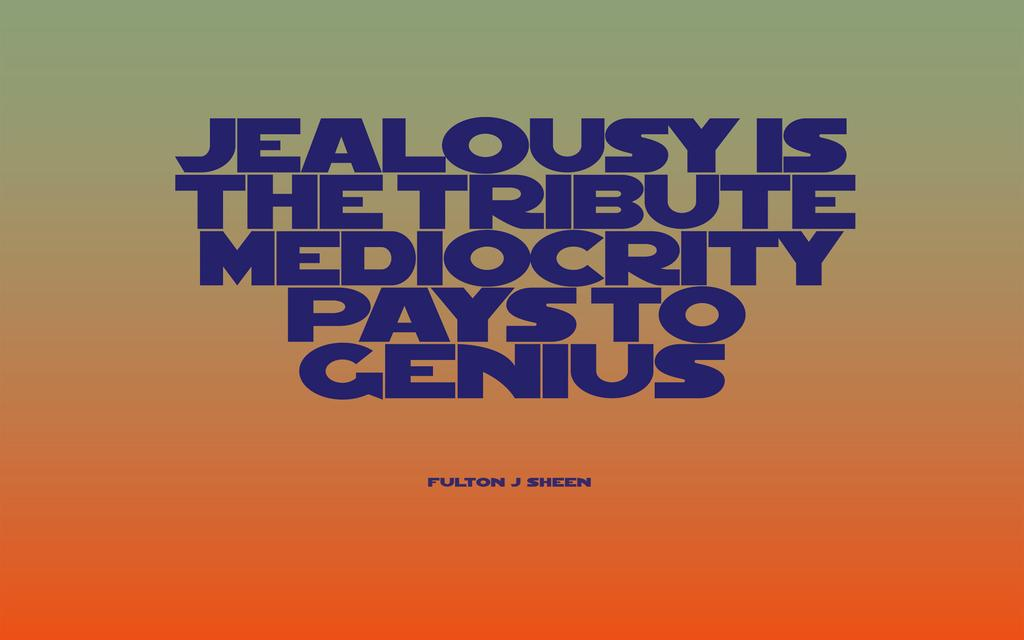<image>
Offer a succinct explanation of the picture presented. Blue lettering spells out a saying about jealousy and its relationship to genuis on a background of green fading to orange. 